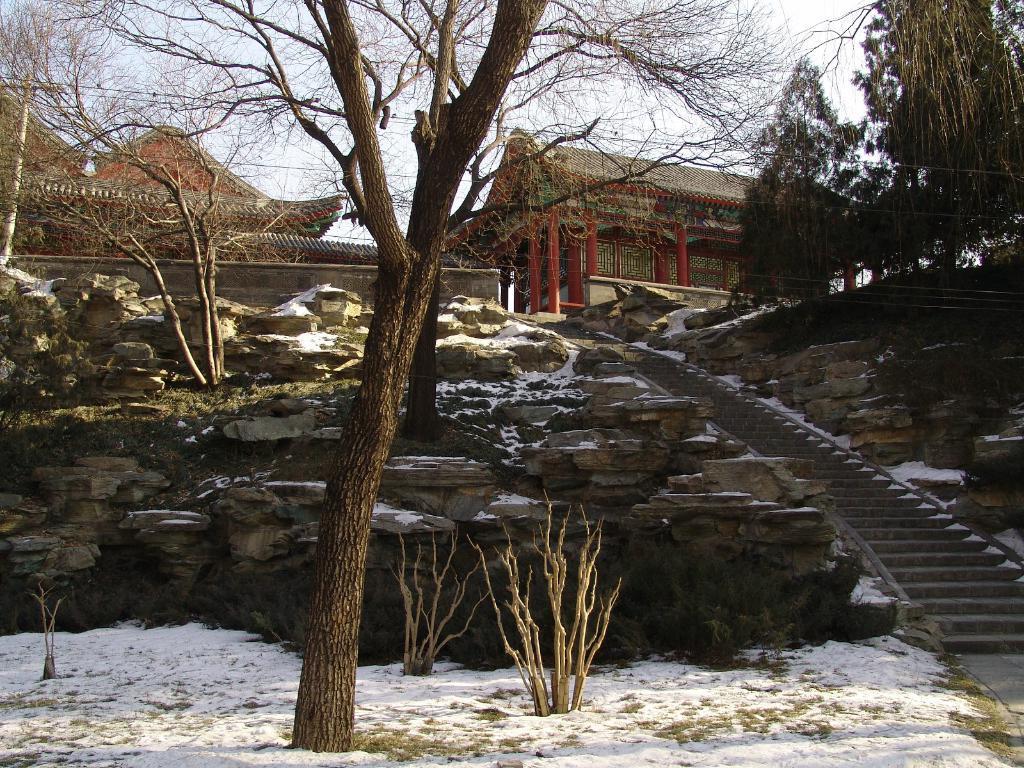Could you give a brief overview of what you see in this image? In this image I can see the stairs. To the side of the stairs there are trees and rocks. In the background I can see the huts and the sky. 